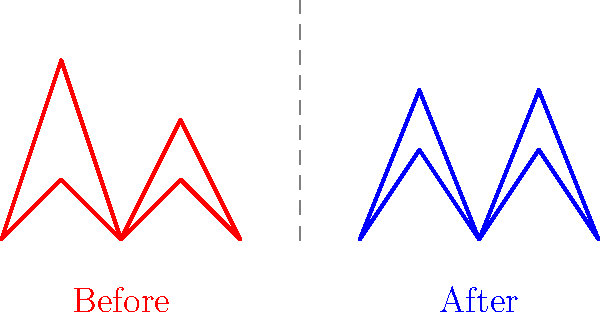Analyze the stick figure illustrations representing gait patterns before and after using 19th-century prosthetic limbs. What is the primary biomechanical improvement observed in the "After" gait pattern, and how might this have impacted patients' mobility and quality of life in 19th-century Canada? To answer this question, let's analyze the gait patterns step-by-step:

1. Before prosthetic use:
   - The red lines show an asymmetrical gait pattern.
   - There's a significant difference in step height between the two legs.
   - The stride length (distance between two consecutive footfalls of the same foot) appears shorter.

2. After prosthetic use:
   - The blue lines demonstrate a more symmetrical gait pattern.
   - The step height is more consistent between both legs.
   - The stride length appears to have increased.

3. Primary biomechanical improvement:
   - The most notable change is the increased symmetry in the gait pattern.
   - This is evident from the more uniform step height and improved alignment of both legs.

4. Impact on mobility and quality of life:
   - Improved symmetry would likely result in:
     a) Better balance and stability while walking
     b) Reduced energy expenditure during movement
     c) Decreased risk of falls and associated injuries
     d) Potential for increased walking speed and distance

5. Context in 19th-century Canada:
   - Improved mobility would have significant social and economic implications:
     a) Enhanced ability to perform manual labor, critical in 19th-century society
     b) Increased independence in daily activities
     c) Better integration into society, potentially reducing stigma associated with physical disabilities
     d) Possible improvement in overall health due to increased physical activity

The primary biomechanical improvement is the increased symmetry in gait pattern, which would have led to enhanced mobility, stability, and energy efficiency for patients using these prosthetics in 19th-century Canada.
Answer: Increased gait symmetry 